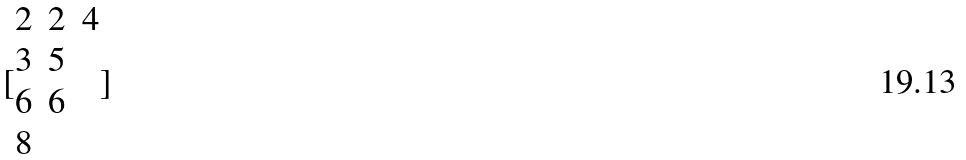Convert formula to latex. <formula><loc_0><loc_0><loc_500><loc_500>[ \begin{matrix} 2 & 2 & 4 \\ 3 & 5 \\ 6 & 6 \\ 8 \end{matrix} ]</formula> 